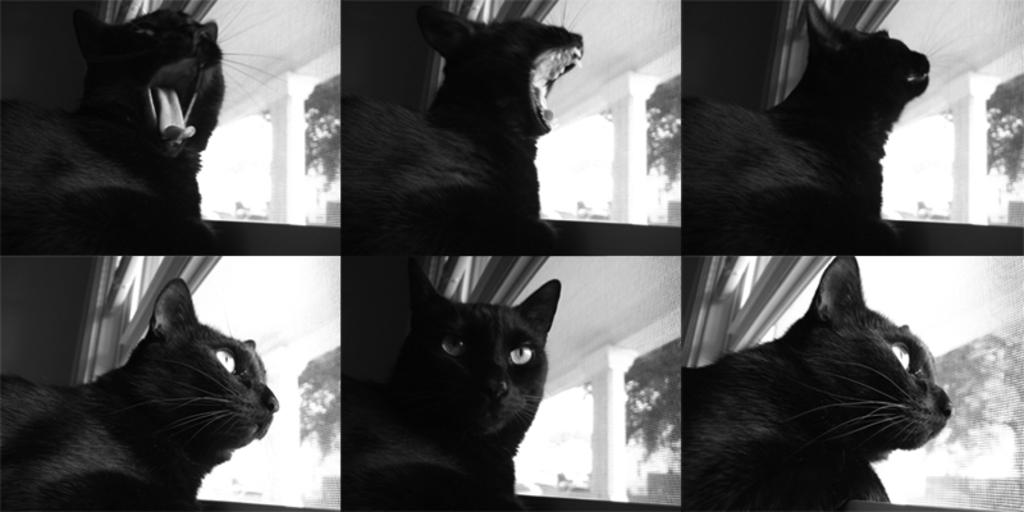What is the composition of the image? The image is a collage of six images. What is the common subject in each image? Each image contains a cat. Where are the cats located? The cats are in a room. What are the cats doing in the room? The cats are looking out through a window. What type of tool is the cat using to fix the broken furniture in the image? There is no tool or broken furniture present in the image; the cats are simply looking out through a window. 